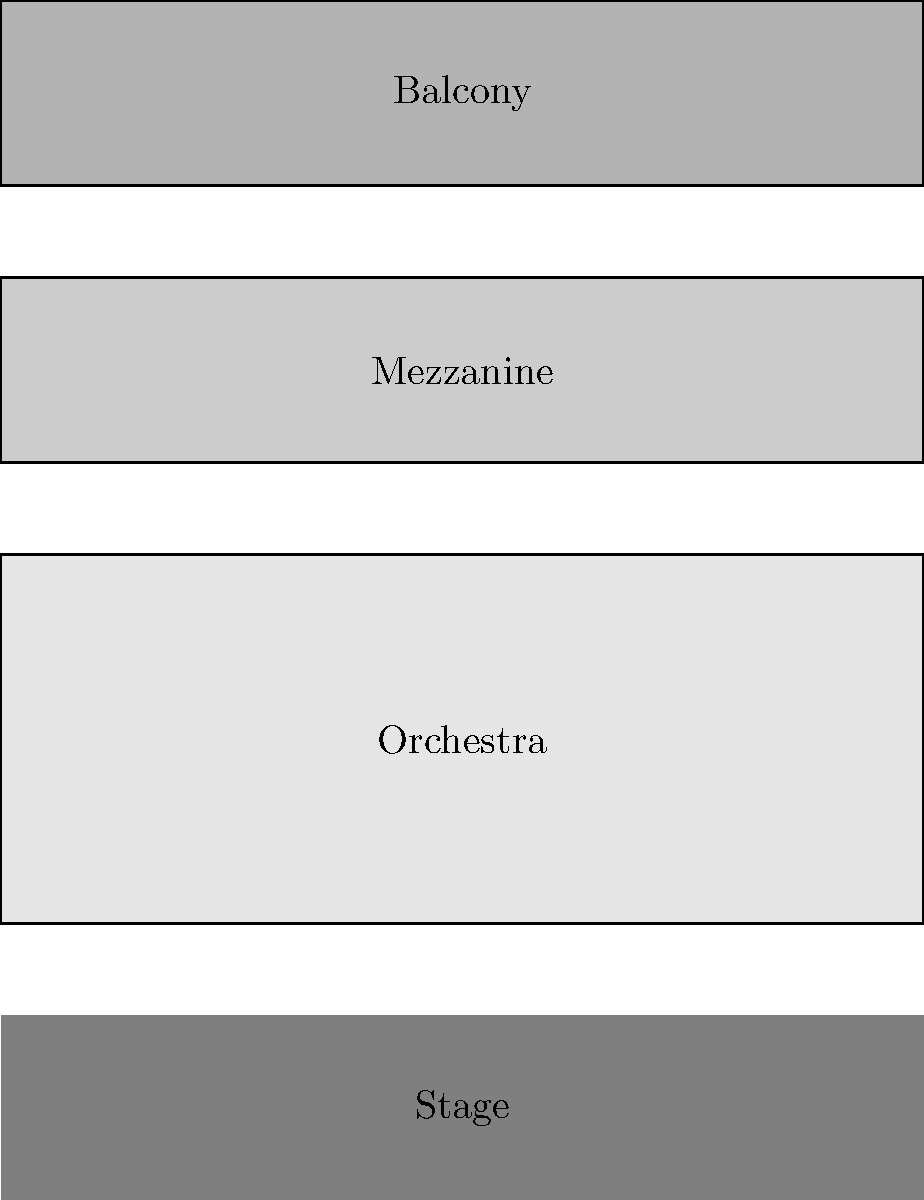Based on the concert venue layout shown, which two seating sections are congruent to each other? To determine which seating sections are congruent, we need to compare their shapes and sizes. Let's analyze each section:

1. Orchestra section: This is the largest section, closest to the stage. It's represented by a rectangle with blue congruence markings on both sides.

2. Mezzanine section: This is the middle section, represented by a rectangle with red congruence markings on both sides. It appears shorter than the Orchestra section.

3. Balcony section: This is the topmost section, represented by a rectangle similar in height to the Mezzanine section but without any congruence markings.

To be congruent, two shapes must have the same size and shape. Looking at the congruence markings:

- The Orchestra section has blue markings on both sides, indicating that its left and right sides are congruent.
- The Mezzanine section has red markings on both sides, indicating that its left and right sides are congruent.
- The Balcony section doesn't have any markings, so we can't determine if its sides are congruent based on this information alone.

However, the question asks which two sections are congruent to each other, not just which sections have congruent sides.

Comparing the sections:
- The Orchestra section is clearly larger than the other two.
- The Mezzanine and Balcony sections appear to have the same height and width.

Therefore, based on their apparent identical size and shape in the diagram, the Mezzanine and Balcony sections are congruent to each other.
Answer: Mezzanine and Balcony 